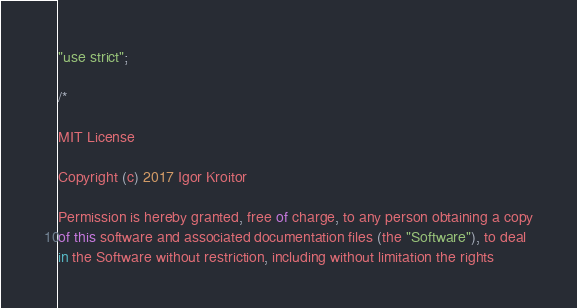<code> <loc_0><loc_0><loc_500><loc_500><_JavaScript_>"use strict";

/*

MIT License

Copyright (c) 2017 Igor Kroitor

Permission is hereby granted, free of charge, to any person obtaining a copy
of this software and associated documentation files (the "Software"), to deal
in the Software without restriction, including without limitation the rights</code> 